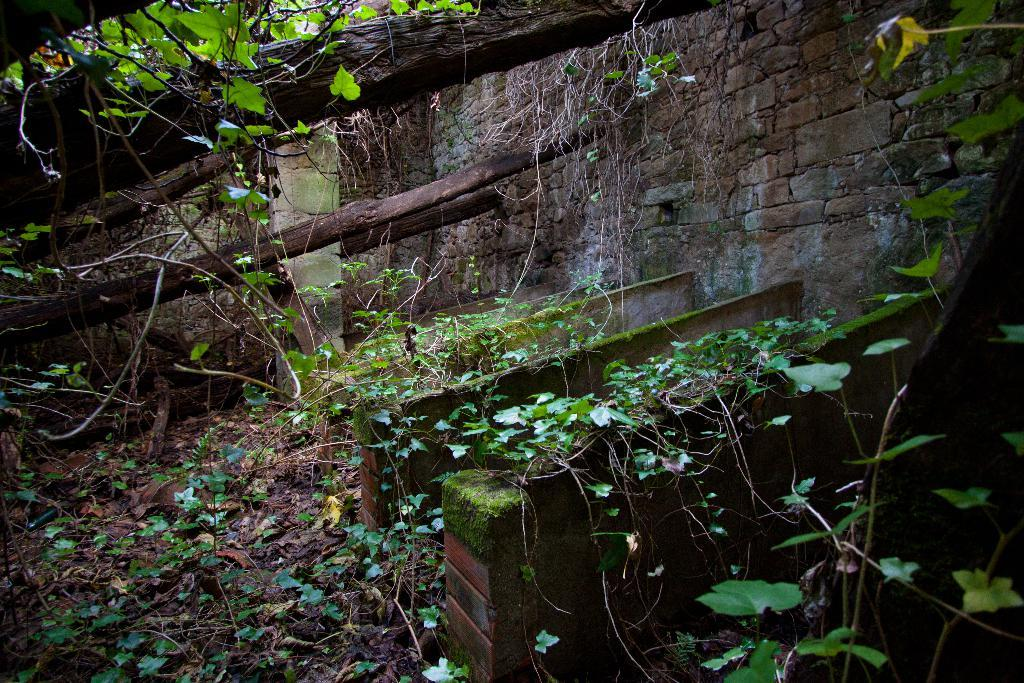What type of vegetation can be seen on the ground in the image? There are leaves and stems on the ground in the image. What type of structure is present in the image? There is a stone wall in the image. Can you see a duck wearing a watch on the railway in the image? No, there is no duck, watch, or railway present in the image. 